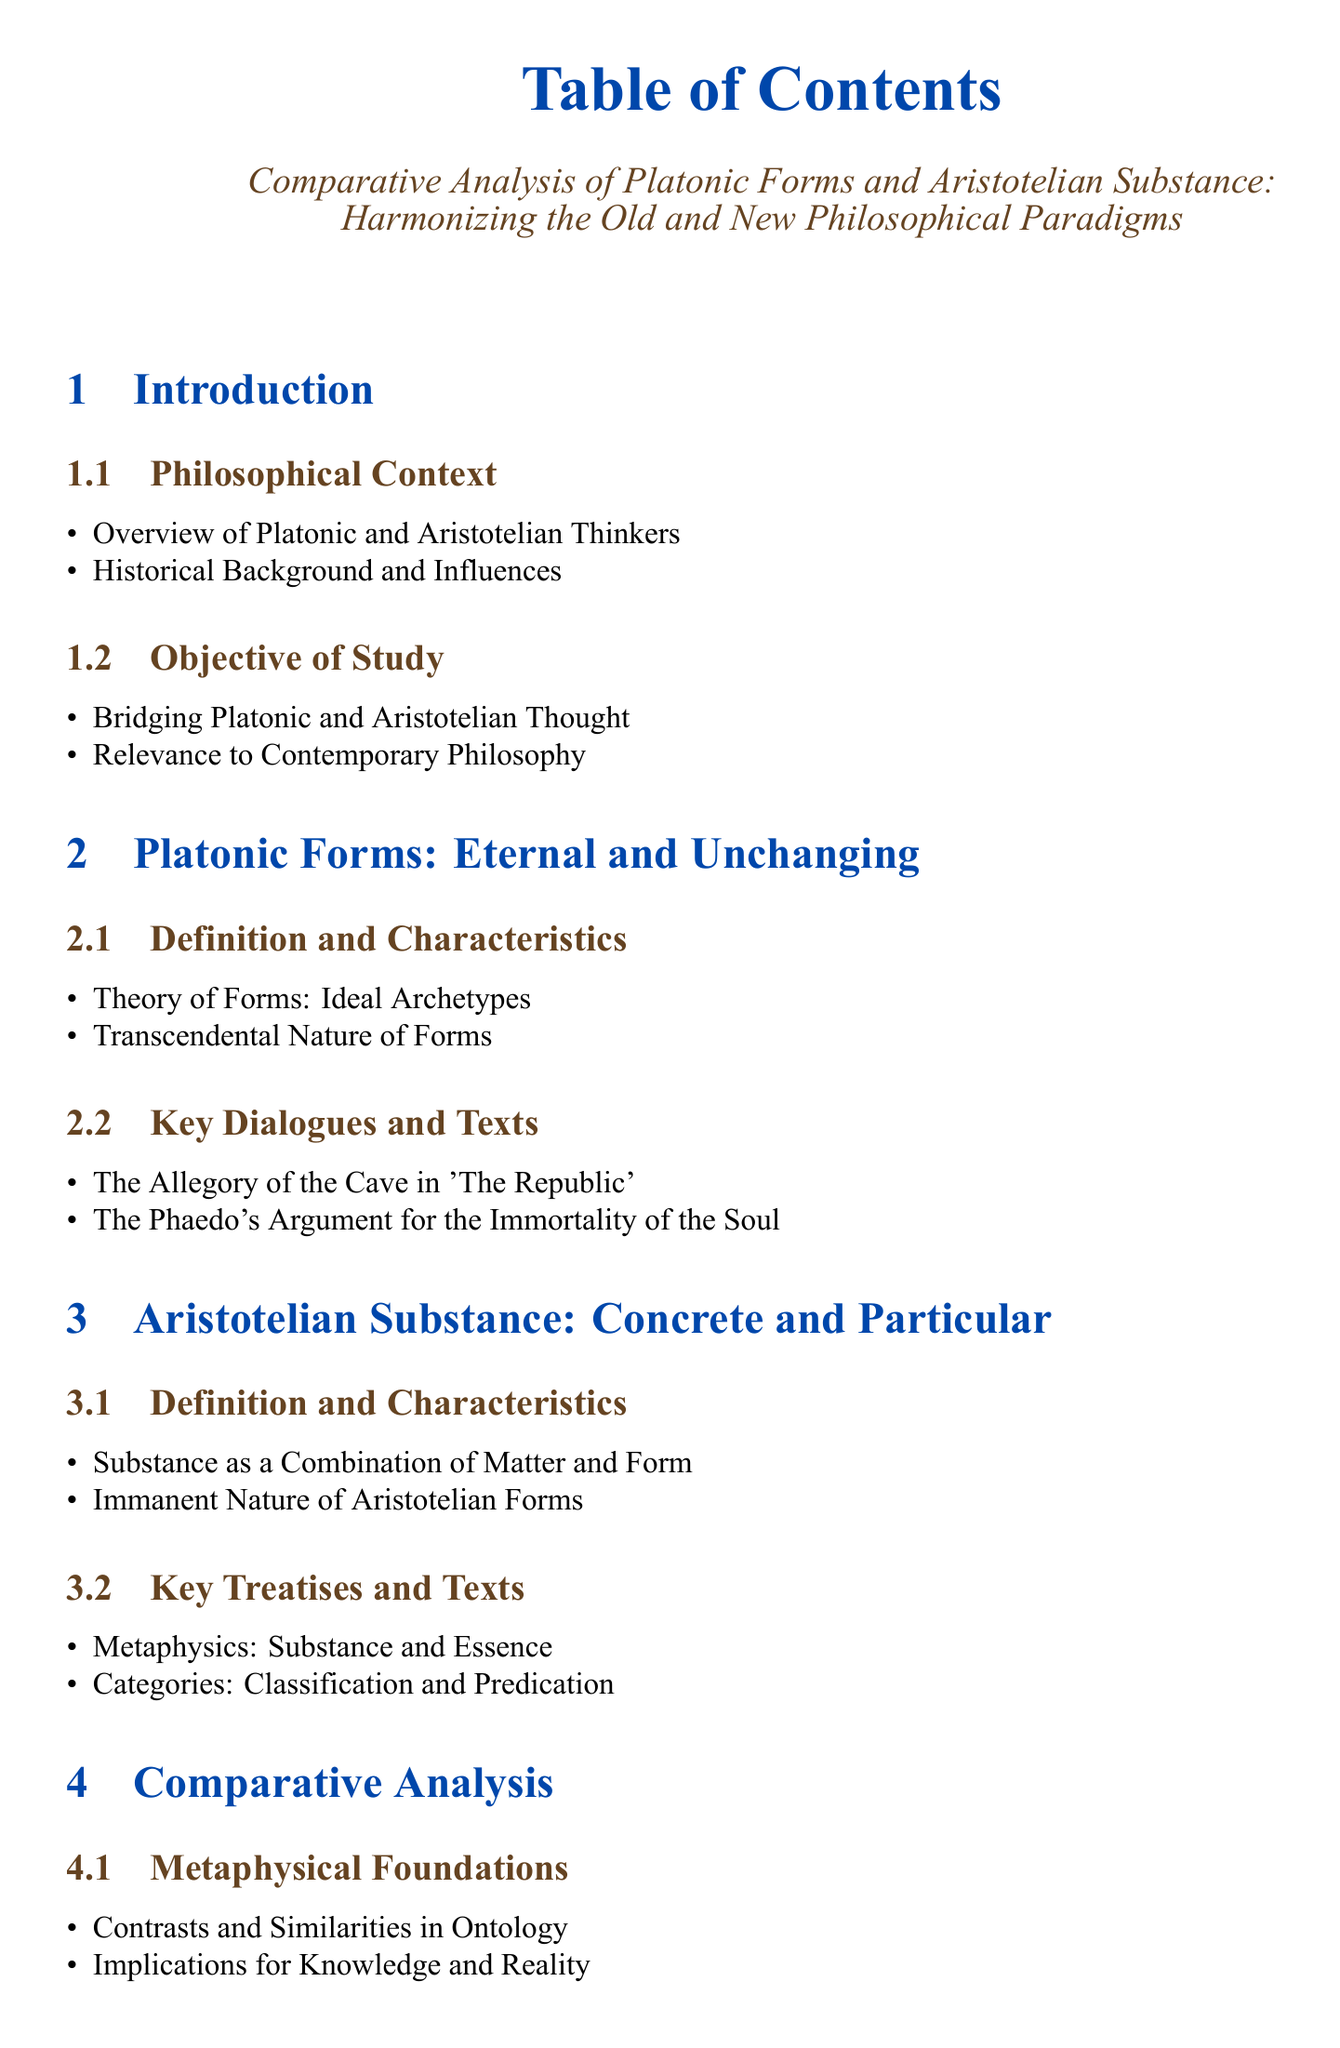What is the title of the document? The title is shown at the top of the Table of Contents as the main focus of the document.
Answer: Comparative Analysis of Platonic Forms and Aristotelian Substance: Harmonizing the Old and New Philosophical Paradigms How many main sections are in the document? The document lists six distinct sections identified in the Table of Contents.
Answer: 6 What is the first key dialogue mentioned under Platonic Forms? The Table of Contents specifies key dialogues related to Platonic Forms, noting the first one.
Answer: The Allegory of the Cave in 'The Republic' Which section discusses Epistemological Frameworks? The section focused on Epistemological Frameworks is specifically labeled for clarity within the comparative section.
Answer: Comparative Analysis What philosophical approach does Plato represent in the analysis? The document clearly contrasts different epistemological approaches and identifies Plato's stance within it.
Answer: Rationalism Who are two subsequent thinkers influenced by these philosophical paradigms? The synthesis section identifies significant thinkers influenced by Platonic and Aristotelian thought.
Answer: Plotinus, Aquinas What is the objective of the study noted in the introduction? The study aims to articulate the primary goal related to Platonic and Aristotelian thoughts outlined in the introductory section.
Answer: Bridging Platonic and Aristotelian Thought What is the final section of the document? The Table of Contents provides a clear outline of the structure, including the last section focused on conclusions.
Answer: Conclusion What area for further research is mentioned in the conclusion? The document outlines potential directions for continued exploration in philosophical thought towards the end.
Answer: Potential Areas for Further Research 